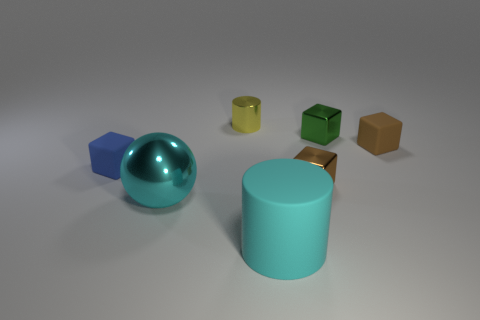How many matte things are both behind the big ball and to the right of the cyan metallic thing?
Your answer should be compact. 1. Is there anything else of the same color as the small cylinder?
Offer a terse response. No. What is the shape of the green thing that is the same material as the yellow cylinder?
Give a very brief answer. Cube. Do the blue rubber block and the cyan matte object have the same size?
Give a very brief answer. No. Does the brown thing to the left of the small green thing have the same material as the big cyan sphere?
Provide a short and direct response. Yes. How many large objects are right of the yellow cylinder that is behind the cyan thing on the left side of the yellow object?
Offer a very short reply. 1. There is a rubber thing that is behind the tiny blue rubber object; is it the same shape as the small blue object?
Offer a terse response. Yes. What number of objects are big cyan cylinders or objects that are left of the rubber cylinder?
Your answer should be very brief. 4. Is the number of blocks on the right side of the yellow metal thing greater than the number of small gray spheres?
Provide a succinct answer. Yes. Is the number of rubber blocks that are in front of the small green cube the same as the number of objects on the right side of the small cylinder?
Your response must be concise. No. 